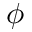Convert formula to latex. <formula><loc_0><loc_0><loc_500><loc_500>\phi</formula> 